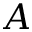<formula> <loc_0><loc_0><loc_500><loc_500>A</formula> 